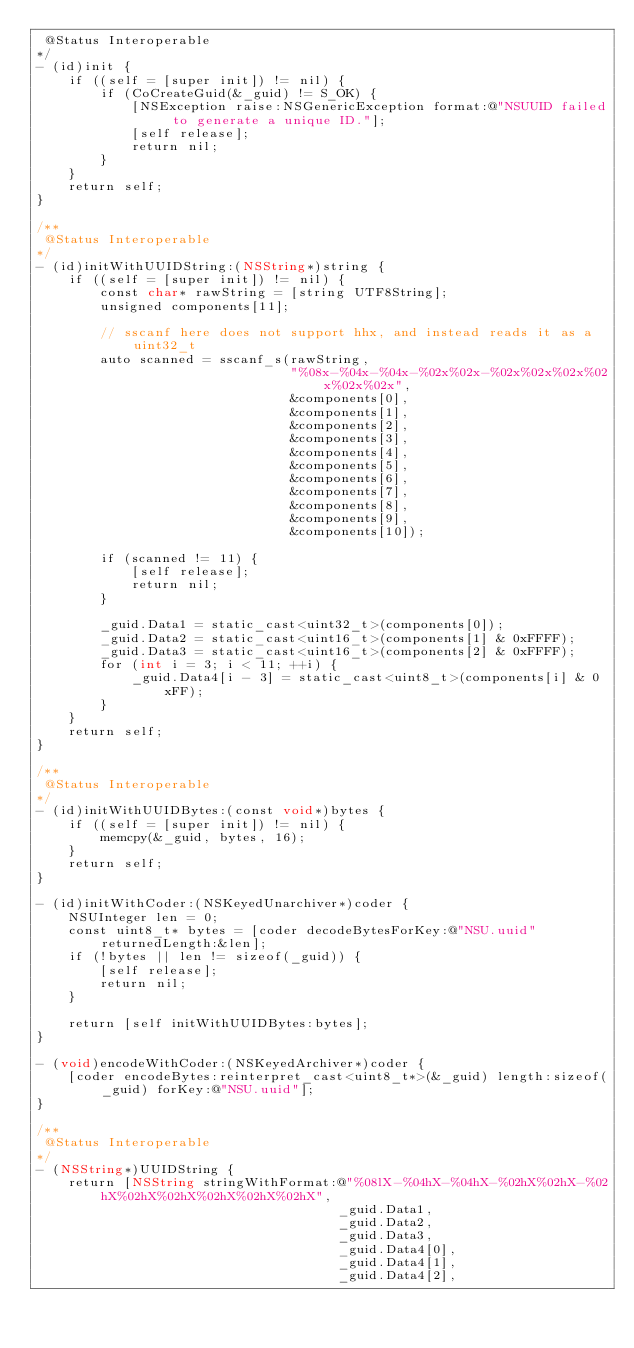<code> <loc_0><loc_0><loc_500><loc_500><_ObjectiveC_> @Status Interoperable
*/
- (id)init {
    if ((self = [super init]) != nil) {
        if (CoCreateGuid(&_guid) != S_OK) {
            [NSException raise:NSGenericException format:@"NSUUID failed to generate a unique ID."];
            [self release];
            return nil;
        }
    }
    return self;
}

/**
 @Status Interoperable
*/
- (id)initWithUUIDString:(NSString*)string {
    if ((self = [super init]) != nil) {
        const char* rawString = [string UTF8String];
        unsigned components[11];

        // sscanf here does not support hhx, and instead reads it as a uint32_t
        auto scanned = sscanf_s(rawString,
                                "%08x-%04x-%04x-%02x%02x-%02x%02x%02x%02x%02x%02x",
                                &components[0],
                                &components[1],
                                &components[2],
                                &components[3],
                                &components[4],
                                &components[5],
                                &components[6],
                                &components[7],
                                &components[8],
                                &components[9],
                                &components[10]);

        if (scanned != 11) {
            [self release];
            return nil;
        }

        _guid.Data1 = static_cast<uint32_t>(components[0]);
        _guid.Data2 = static_cast<uint16_t>(components[1] & 0xFFFF);
        _guid.Data3 = static_cast<uint16_t>(components[2] & 0xFFFF);
        for (int i = 3; i < 11; ++i) {
            _guid.Data4[i - 3] = static_cast<uint8_t>(components[i] & 0xFF);
        }
    }
    return self;
}

/**
 @Status Interoperable
*/
- (id)initWithUUIDBytes:(const void*)bytes {
    if ((self = [super init]) != nil) {
        memcpy(&_guid, bytes, 16);
    }
    return self;
}

- (id)initWithCoder:(NSKeyedUnarchiver*)coder {
    NSUInteger len = 0;
    const uint8_t* bytes = [coder decodeBytesForKey:@"NSU.uuid" returnedLength:&len];
    if (!bytes || len != sizeof(_guid)) {
        [self release];
        return nil;
    }

    return [self initWithUUIDBytes:bytes];
}

- (void)encodeWithCoder:(NSKeyedArchiver*)coder {
    [coder encodeBytes:reinterpret_cast<uint8_t*>(&_guid) length:sizeof(_guid) forKey:@"NSU.uuid"];
}

/**
 @Status Interoperable
*/
- (NSString*)UUIDString {
    return [NSString stringWithFormat:@"%08lX-%04hX-%04hX-%02hX%02hX-%02hX%02hX%02hX%02hX%02hX%02hX",
                                      _guid.Data1,
                                      _guid.Data2,
                                      _guid.Data3,
                                      _guid.Data4[0],
                                      _guid.Data4[1],
                                      _guid.Data4[2],</code> 